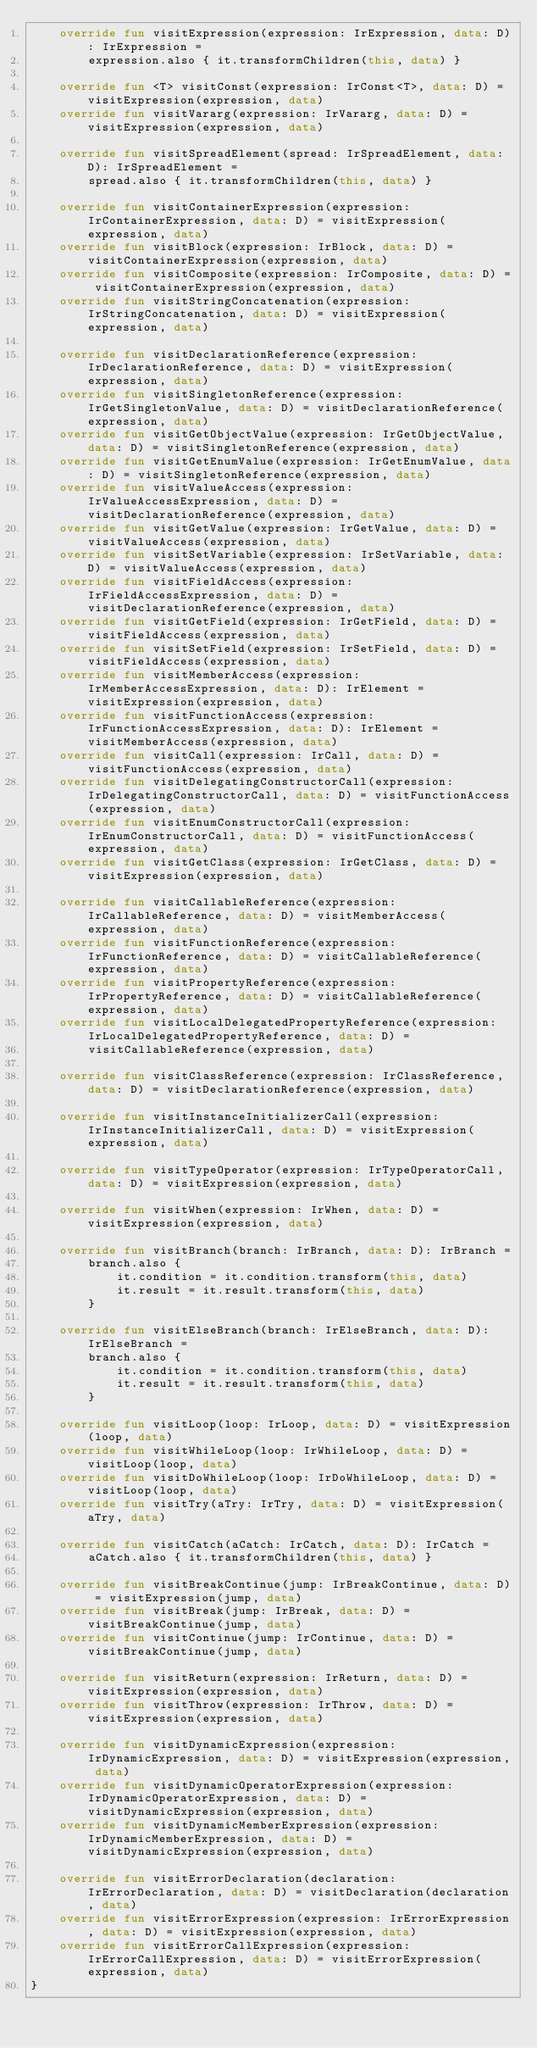<code> <loc_0><loc_0><loc_500><loc_500><_Kotlin_>    override fun visitExpression(expression: IrExpression, data: D): IrExpression =
        expression.also { it.transformChildren(this, data) }

    override fun <T> visitConst(expression: IrConst<T>, data: D) = visitExpression(expression, data)
    override fun visitVararg(expression: IrVararg, data: D) = visitExpression(expression, data)

    override fun visitSpreadElement(spread: IrSpreadElement, data: D): IrSpreadElement =
        spread.also { it.transformChildren(this, data) }

    override fun visitContainerExpression(expression: IrContainerExpression, data: D) = visitExpression(expression, data)
    override fun visitBlock(expression: IrBlock, data: D) = visitContainerExpression(expression, data)
    override fun visitComposite(expression: IrComposite, data: D) = visitContainerExpression(expression, data)
    override fun visitStringConcatenation(expression: IrStringConcatenation, data: D) = visitExpression(expression, data)

    override fun visitDeclarationReference(expression: IrDeclarationReference, data: D) = visitExpression(expression, data)
    override fun visitSingletonReference(expression: IrGetSingletonValue, data: D) = visitDeclarationReference(expression, data)
    override fun visitGetObjectValue(expression: IrGetObjectValue, data: D) = visitSingletonReference(expression, data)
    override fun visitGetEnumValue(expression: IrGetEnumValue, data: D) = visitSingletonReference(expression, data)
    override fun visitValueAccess(expression: IrValueAccessExpression, data: D) = visitDeclarationReference(expression, data)
    override fun visitGetValue(expression: IrGetValue, data: D) = visitValueAccess(expression, data)
    override fun visitSetVariable(expression: IrSetVariable, data: D) = visitValueAccess(expression, data)
    override fun visitFieldAccess(expression: IrFieldAccessExpression, data: D) = visitDeclarationReference(expression, data)
    override fun visitGetField(expression: IrGetField, data: D) = visitFieldAccess(expression, data)
    override fun visitSetField(expression: IrSetField, data: D) = visitFieldAccess(expression, data)
    override fun visitMemberAccess(expression: IrMemberAccessExpression, data: D): IrElement = visitExpression(expression, data)
    override fun visitFunctionAccess(expression: IrFunctionAccessExpression, data: D): IrElement = visitMemberAccess(expression, data)
    override fun visitCall(expression: IrCall, data: D) = visitFunctionAccess(expression, data)
    override fun visitDelegatingConstructorCall(expression: IrDelegatingConstructorCall, data: D) = visitFunctionAccess(expression, data)
    override fun visitEnumConstructorCall(expression: IrEnumConstructorCall, data: D) = visitFunctionAccess(expression, data)
    override fun visitGetClass(expression: IrGetClass, data: D) = visitExpression(expression, data)

    override fun visitCallableReference(expression: IrCallableReference, data: D) = visitMemberAccess(expression, data)
    override fun visitFunctionReference(expression: IrFunctionReference, data: D) = visitCallableReference(expression, data)
    override fun visitPropertyReference(expression: IrPropertyReference, data: D) = visitCallableReference(expression, data)
    override fun visitLocalDelegatedPropertyReference(expression: IrLocalDelegatedPropertyReference, data: D) =
        visitCallableReference(expression, data)

    override fun visitClassReference(expression: IrClassReference, data: D) = visitDeclarationReference(expression, data)

    override fun visitInstanceInitializerCall(expression: IrInstanceInitializerCall, data: D) = visitExpression(expression, data)

    override fun visitTypeOperator(expression: IrTypeOperatorCall, data: D) = visitExpression(expression, data)

    override fun visitWhen(expression: IrWhen, data: D) = visitExpression(expression, data)

    override fun visitBranch(branch: IrBranch, data: D): IrBranch =
        branch.also {
            it.condition = it.condition.transform(this, data)
            it.result = it.result.transform(this, data)
        }

    override fun visitElseBranch(branch: IrElseBranch, data: D): IrElseBranch =
        branch.also {
            it.condition = it.condition.transform(this, data)
            it.result = it.result.transform(this, data)
        }

    override fun visitLoop(loop: IrLoop, data: D) = visitExpression(loop, data)
    override fun visitWhileLoop(loop: IrWhileLoop, data: D) = visitLoop(loop, data)
    override fun visitDoWhileLoop(loop: IrDoWhileLoop, data: D) = visitLoop(loop, data)
    override fun visitTry(aTry: IrTry, data: D) = visitExpression(aTry, data)

    override fun visitCatch(aCatch: IrCatch, data: D): IrCatch =
        aCatch.also { it.transformChildren(this, data) }

    override fun visitBreakContinue(jump: IrBreakContinue, data: D) = visitExpression(jump, data)
    override fun visitBreak(jump: IrBreak, data: D) = visitBreakContinue(jump, data)
    override fun visitContinue(jump: IrContinue, data: D) = visitBreakContinue(jump, data)

    override fun visitReturn(expression: IrReturn, data: D) = visitExpression(expression, data)
    override fun visitThrow(expression: IrThrow, data: D) = visitExpression(expression, data)

    override fun visitDynamicExpression(expression: IrDynamicExpression, data: D) = visitExpression(expression, data)
    override fun visitDynamicOperatorExpression(expression: IrDynamicOperatorExpression, data: D) = visitDynamicExpression(expression, data)
    override fun visitDynamicMemberExpression(expression: IrDynamicMemberExpression, data: D) = visitDynamicExpression(expression, data)

    override fun visitErrorDeclaration(declaration: IrErrorDeclaration, data: D) = visitDeclaration(declaration, data)
    override fun visitErrorExpression(expression: IrErrorExpression, data: D) = visitExpression(expression, data)
    override fun visitErrorCallExpression(expression: IrErrorCallExpression, data: D) = visitErrorExpression(expression, data)
}
</code> 